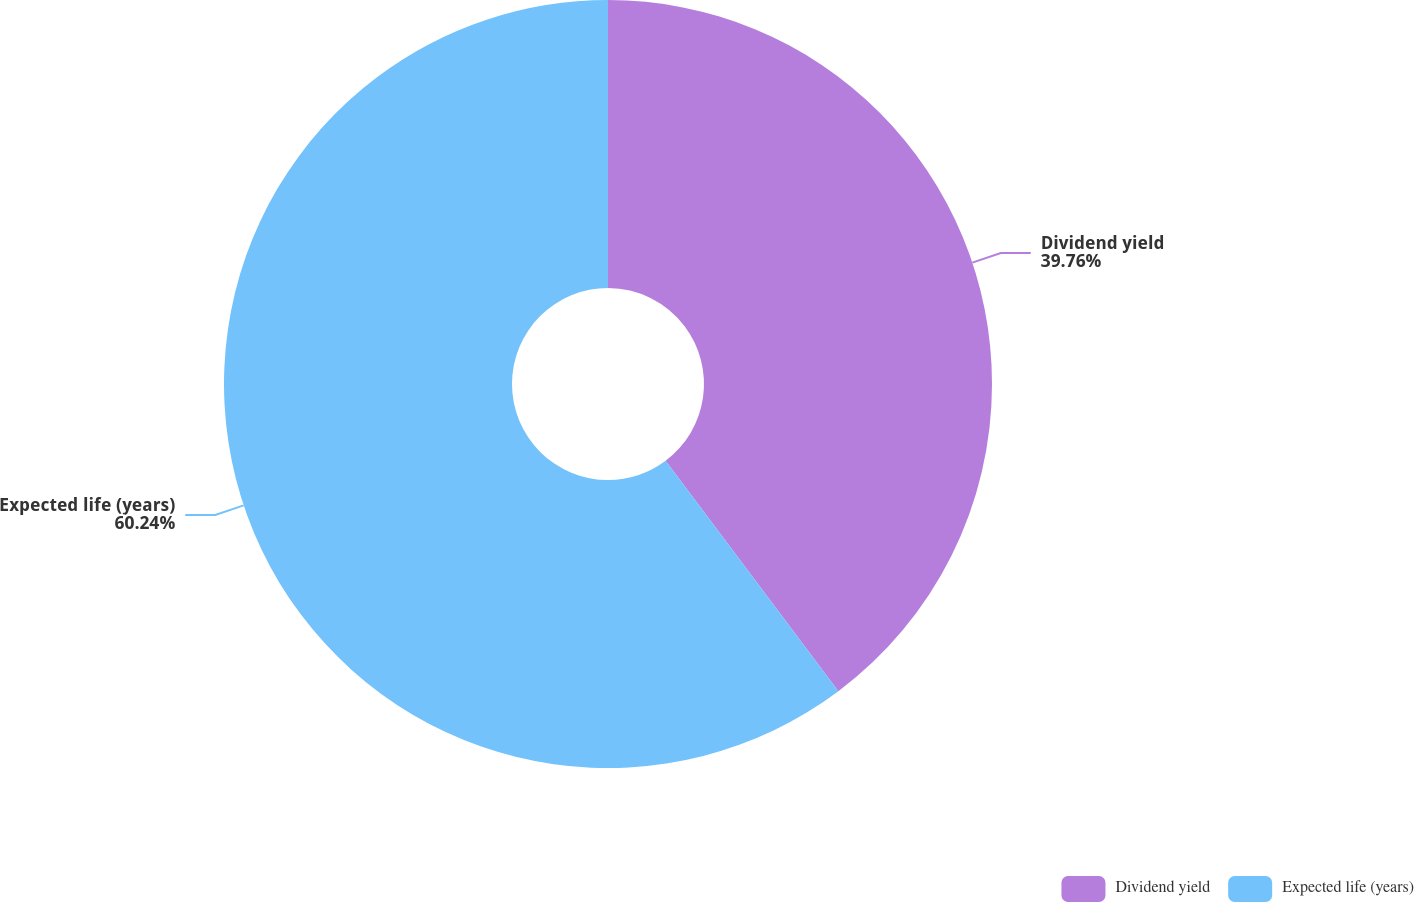Convert chart. <chart><loc_0><loc_0><loc_500><loc_500><pie_chart><fcel>Dividend yield<fcel>Expected life (years)<nl><fcel>39.76%<fcel>60.24%<nl></chart> 